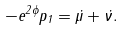<formula> <loc_0><loc_0><loc_500><loc_500>- e ^ { 2 \phi } p _ { 1 } = \dot { \mu } + \dot { \nu } .</formula> 